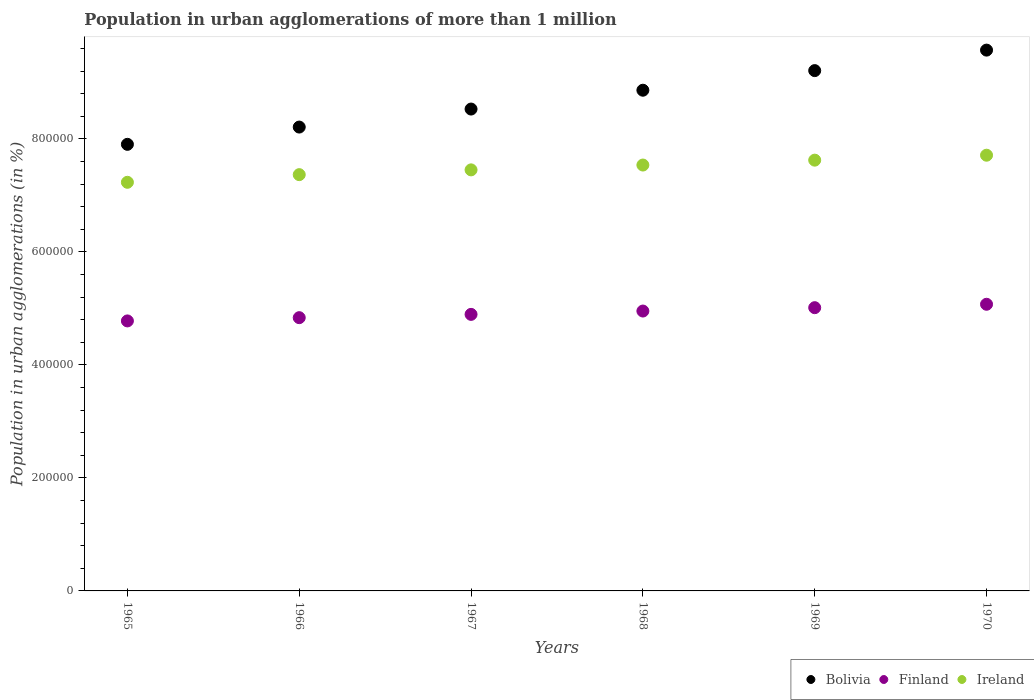Is the number of dotlines equal to the number of legend labels?
Make the answer very short. Yes. What is the population in urban agglomerations in Ireland in 1966?
Keep it short and to the point. 7.37e+05. Across all years, what is the maximum population in urban agglomerations in Finland?
Offer a terse response. 5.07e+05. Across all years, what is the minimum population in urban agglomerations in Bolivia?
Provide a succinct answer. 7.90e+05. In which year was the population in urban agglomerations in Finland maximum?
Your answer should be very brief. 1970. In which year was the population in urban agglomerations in Bolivia minimum?
Keep it short and to the point. 1965. What is the total population in urban agglomerations in Finland in the graph?
Offer a very short reply. 2.95e+06. What is the difference between the population in urban agglomerations in Ireland in 1965 and that in 1968?
Ensure brevity in your answer.  -3.06e+04. What is the difference between the population in urban agglomerations in Ireland in 1966 and the population in urban agglomerations in Bolivia in 1965?
Your response must be concise. -5.36e+04. What is the average population in urban agglomerations in Ireland per year?
Offer a terse response. 7.49e+05. In the year 1969, what is the difference between the population in urban agglomerations in Bolivia and population in urban agglomerations in Ireland?
Ensure brevity in your answer.  1.58e+05. What is the ratio of the population in urban agglomerations in Ireland in 1965 to that in 1970?
Provide a succinct answer. 0.94. Is the population in urban agglomerations in Bolivia in 1967 less than that in 1970?
Your answer should be compact. Yes. Is the difference between the population in urban agglomerations in Bolivia in 1966 and 1969 greater than the difference between the population in urban agglomerations in Ireland in 1966 and 1969?
Your answer should be compact. No. What is the difference between the highest and the second highest population in urban agglomerations in Finland?
Your answer should be compact. 6036. What is the difference between the highest and the lowest population in urban agglomerations in Finland?
Provide a short and direct response. 2.95e+04. In how many years, is the population in urban agglomerations in Finland greater than the average population in urban agglomerations in Finland taken over all years?
Provide a succinct answer. 3. Is the sum of the population in urban agglomerations in Ireland in 1969 and 1970 greater than the maximum population in urban agglomerations in Bolivia across all years?
Give a very brief answer. Yes. Is it the case that in every year, the sum of the population in urban agglomerations in Bolivia and population in urban agglomerations in Ireland  is greater than the population in urban agglomerations in Finland?
Your answer should be very brief. Yes. Is the population in urban agglomerations in Bolivia strictly less than the population in urban agglomerations in Ireland over the years?
Ensure brevity in your answer.  No. How many dotlines are there?
Keep it short and to the point. 3. How many years are there in the graph?
Ensure brevity in your answer.  6. Does the graph contain grids?
Ensure brevity in your answer.  No. Where does the legend appear in the graph?
Provide a succinct answer. Bottom right. How are the legend labels stacked?
Ensure brevity in your answer.  Horizontal. What is the title of the graph?
Provide a succinct answer. Population in urban agglomerations of more than 1 million. What is the label or title of the Y-axis?
Your answer should be compact. Population in urban agglomerations (in %). What is the Population in urban agglomerations (in %) of Bolivia in 1965?
Your answer should be compact. 7.90e+05. What is the Population in urban agglomerations (in %) in Finland in 1965?
Provide a succinct answer. 4.78e+05. What is the Population in urban agglomerations (in %) of Ireland in 1965?
Offer a terse response. 7.23e+05. What is the Population in urban agglomerations (in %) in Bolivia in 1966?
Give a very brief answer. 8.21e+05. What is the Population in urban agglomerations (in %) in Finland in 1966?
Your answer should be compact. 4.84e+05. What is the Population in urban agglomerations (in %) in Ireland in 1966?
Make the answer very short. 7.37e+05. What is the Population in urban agglomerations (in %) in Bolivia in 1967?
Offer a very short reply. 8.53e+05. What is the Population in urban agglomerations (in %) of Finland in 1967?
Keep it short and to the point. 4.89e+05. What is the Population in urban agglomerations (in %) in Ireland in 1967?
Offer a very short reply. 7.45e+05. What is the Population in urban agglomerations (in %) in Bolivia in 1968?
Your response must be concise. 8.86e+05. What is the Population in urban agglomerations (in %) in Finland in 1968?
Provide a succinct answer. 4.95e+05. What is the Population in urban agglomerations (in %) in Ireland in 1968?
Give a very brief answer. 7.54e+05. What is the Population in urban agglomerations (in %) of Bolivia in 1969?
Make the answer very short. 9.21e+05. What is the Population in urban agglomerations (in %) in Finland in 1969?
Offer a very short reply. 5.01e+05. What is the Population in urban agglomerations (in %) of Ireland in 1969?
Give a very brief answer. 7.62e+05. What is the Population in urban agglomerations (in %) of Bolivia in 1970?
Your answer should be compact. 9.57e+05. What is the Population in urban agglomerations (in %) in Finland in 1970?
Your response must be concise. 5.07e+05. What is the Population in urban agglomerations (in %) in Ireland in 1970?
Your answer should be very brief. 7.71e+05. Across all years, what is the maximum Population in urban agglomerations (in %) of Bolivia?
Your answer should be very brief. 9.57e+05. Across all years, what is the maximum Population in urban agglomerations (in %) of Finland?
Your response must be concise. 5.07e+05. Across all years, what is the maximum Population in urban agglomerations (in %) in Ireland?
Keep it short and to the point. 7.71e+05. Across all years, what is the minimum Population in urban agglomerations (in %) of Bolivia?
Offer a terse response. 7.90e+05. Across all years, what is the minimum Population in urban agglomerations (in %) of Finland?
Give a very brief answer. 4.78e+05. Across all years, what is the minimum Population in urban agglomerations (in %) in Ireland?
Give a very brief answer. 7.23e+05. What is the total Population in urban agglomerations (in %) of Bolivia in the graph?
Provide a succinct answer. 5.23e+06. What is the total Population in urban agglomerations (in %) of Finland in the graph?
Offer a terse response. 2.95e+06. What is the total Population in urban agglomerations (in %) of Ireland in the graph?
Ensure brevity in your answer.  4.49e+06. What is the difference between the Population in urban agglomerations (in %) of Bolivia in 1965 and that in 1966?
Offer a terse response. -3.06e+04. What is the difference between the Population in urban agglomerations (in %) in Finland in 1965 and that in 1966?
Give a very brief answer. -5754. What is the difference between the Population in urban agglomerations (in %) of Ireland in 1965 and that in 1966?
Offer a terse response. -1.35e+04. What is the difference between the Population in urban agglomerations (in %) in Bolivia in 1965 and that in 1967?
Offer a terse response. -6.24e+04. What is the difference between the Population in urban agglomerations (in %) in Finland in 1965 and that in 1967?
Make the answer very short. -1.16e+04. What is the difference between the Population in urban agglomerations (in %) of Ireland in 1965 and that in 1967?
Provide a succinct answer. -2.20e+04. What is the difference between the Population in urban agglomerations (in %) of Bolivia in 1965 and that in 1968?
Offer a very short reply. -9.58e+04. What is the difference between the Population in urban agglomerations (in %) in Finland in 1965 and that in 1968?
Give a very brief answer. -1.75e+04. What is the difference between the Population in urban agglomerations (in %) of Ireland in 1965 and that in 1968?
Ensure brevity in your answer.  -3.06e+04. What is the difference between the Population in urban agglomerations (in %) in Bolivia in 1965 and that in 1969?
Your answer should be very brief. -1.30e+05. What is the difference between the Population in urban agglomerations (in %) of Finland in 1965 and that in 1969?
Provide a succinct answer. -2.34e+04. What is the difference between the Population in urban agglomerations (in %) in Ireland in 1965 and that in 1969?
Your answer should be compact. -3.92e+04. What is the difference between the Population in urban agglomerations (in %) in Bolivia in 1965 and that in 1970?
Provide a succinct answer. -1.67e+05. What is the difference between the Population in urban agglomerations (in %) in Finland in 1965 and that in 1970?
Provide a short and direct response. -2.95e+04. What is the difference between the Population in urban agglomerations (in %) of Ireland in 1965 and that in 1970?
Offer a very short reply. -4.79e+04. What is the difference between the Population in urban agglomerations (in %) of Bolivia in 1966 and that in 1967?
Offer a very short reply. -3.19e+04. What is the difference between the Population in urban agglomerations (in %) in Finland in 1966 and that in 1967?
Your response must be concise. -5823. What is the difference between the Population in urban agglomerations (in %) in Ireland in 1966 and that in 1967?
Give a very brief answer. -8451. What is the difference between the Population in urban agglomerations (in %) of Bolivia in 1966 and that in 1968?
Make the answer very short. -6.52e+04. What is the difference between the Population in urban agglomerations (in %) of Finland in 1966 and that in 1968?
Your answer should be compact. -1.17e+04. What is the difference between the Population in urban agglomerations (in %) in Ireland in 1966 and that in 1968?
Your answer should be compact. -1.70e+04. What is the difference between the Population in urban agglomerations (in %) in Bolivia in 1966 and that in 1969?
Your answer should be very brief. -9.99e+04. What is the difference between the Population in urban agglomerations (in %) in Finland in 1966 and that in 1969?
Provide a succinct answer. -1.77e+04. What is the difference between the Population in urban agglomerations (in %) of Ireland in 1966 and that in 1969?
Your response must be concise. -2.56e+04. What is the difference between the Population in urban agglomerations (in %) of Bolivia in 1966 and that in 1970?
Your answer should be very brief. -1.36e+05. What is the difference between the Population in urban agglomerations (in %) of Finland in 1966 and that in 1970?
Give a very brief answer. -2.37e+04. What is the difference between the Population in urban agglomerations (in %) in Ireland in 1966 and that in 1970?
Your answer should be compact. -3.44e+04. What is the difference between the Population in urban agglomerations (in %) in Bolivia in 1967 and that in 1968?
Offer a very short reply. -3.33e+04. What is the difference between the Population in urban agglomerations (in %) of Finland in 1967 and that in 1968?
Make the answer very short. -5902. What is the difference between the Population in urban agglomerations (in %) in Ireland in 1967 and that in 1968?
Your answer should be very brief. -8560. What is the difference between the Population in urban agglomerations (in %) of Bolivia in 1967 and that in 1969?
Give a very brief answer. -6.80e+04. What is the difference between the Population in urban agglomerations (in %) in Finland in 1967 and that in 1969?
Offer a very short reply. -1.19e+04. What is the difference between the Population in urban agglomerations (in %) in Ireland in 1967 and that in 1969?
Give a very brief answer. -1.72e+04. What is the difference between the Population in urban agglomerations (in %) in Bolivia in 1967 and that in 1970?
Offer a terse response. -1.04e+05. What is the difference between the Population in urban agglomerations (in %) in Finland in 1967 and that in 1970?
Your response must be concise. -1.79e+04. What is the difference between the Population in urban agglomerations (in %) in Ireland in 1967 and that in 1970?
Your answer should be very brief. -2.59e+04. What is the difference between the Population in urban agglomerations (in %) in Bolivia in 1968 and that in 1969?
Give a very brief answer. -3.47e+04. What is the difference between the Population in urban agglomerations (in %) in Finland in 1968 and that in 1969?
Offer a terse response. -5956. What is the difference between the Population in urban agglomerations (in %) of Ireland in 1968 and that in 1969?
Make the answer very short. -8634. What is the difference between the Population in urban agglomerations (in %) of Bolivia in 1968 and that in 1970?
Ensure brevity in your answer.  -7.10e+04. What is the difference between the Population in urban agglomerations (in %) in Finland in 1968 and that in 1970?
Keep it short and to the point. -1.20e+04. What is the difference between the Population in urban agglomerations (in %) in Ireland in 1968 and that in 1970?
Give a very brief answer. -1.74e+04. What is the difference between the Population in urban agglomerations (in %) of Bolivia in 1969 and that in 1970?
Ensure brevity in your answer.  -3.63e+04. What is the difference between the Population in urban agglomerations (in %) in Finland in 1969 and that in 1970?
Your answer should be very brief. -6036. What is the difference between the Population in urban agglomerations (in %) in Ireland in 1969 and that in 1970?
Offer a very short reply. -8746. What is the difference between the Population in urban agglomerations (in %) of Bolivia in 1965 and the Population in urban agglomerations (in %) of Finland in 1966?
Keep it short and to the point. 3.07e+05. What is the difference between the Population in urban agglomerations (in %) of Bolivia in 1965 and the Population in urban agglomerations (in %) of Ireland in 1966?
Provide a succinct answer. 5.36e+04. What is the difference between the Population in urban agglomerations (in %) of Finland in 1965 and the Population in urban agglomerations (in %) of Ireland in 1966?
Your answer should be compact. -2.59e+05. What is the difference between the Population in urban agglomerations (in %) of Bolivia in 1965 and the Population in urban agglomerations (in %) of Finland in 1967?
Provide a short and direct response. 3.01e+05. What is the difference between the Population in urban agglomerations (in %) of Bolivia in 1965 and the Population in urban agglomerations (in %) of Ireland in 1967?
Ensure brevity in your answer.  4.52e+04. What is the difference between the Population in urban agglomerations (in %) in Finland in 1965 and the Population in urban agglomerations (in %) in Ireland in 1967?
Give a very brief answer. -2.67e+05. What is the difference between the Population in urban agglomerations (in %) of Bolivia in 1965 and the Population in urban agglomerations (in %) of Finland in 1968?
Provide a short and direct response. 2.95e+05. What is the difference between the Population in urban agglomerations (in %) of Bolivia in 1965 and the Population in urban agglomerations (in %) of Ireland in 1968?
Your answer should be compact. 3.66e+04. What is the difference between the Population in urban agglomerations (in %) in Finland in 1965 and the Population in urban agglomerations (in %) in Ireland in 1968?
Give a very brief answer. -2.76e+05. What is the difference between the Population in urban agglomerations (in %) of Bolivia in 1965 and the Population in urban agglomerations (in %) of Finland in 1969?
Make the answer very short. 2.89e+05. What is the difference between the Population in urban agglomerations (in %) of Bolivia in 1965 and the Population in urban agglomerations (in %) of Ireland in 1969?
Your response must be concise. 2.80e+04. What is the difference between the Population in urban agglomerations (in %) of Finland in 1965 and the Population in urban agglomerations (in %) of Ireland in 1969?
Offer a terse response. -2.85e+05. What is the difference between the Population in urban agglomerations (in %) in Bolivia in 1965 and the Population in urban agglomerations (in %) in Finland in 1970?
Your response must be concise. 2.83e+05. What is the difference between the Population in urban agglomerations (in %) in Bolivia in 1965 and the Population in urban agglomerations (in %) in Ireland in 1970?
Keep it short and to the point. 1.93e+04. What is the difference between the Population in urban agglomerations (in %) of Finland in 1965 and the Population in urban agglomerations (in %) of Ireland in 1970?
Give a very brief answer. -2.93e+05. What is the difference between the Population in urban agglomerations (in %) of Bolivia in 1966 and the Population in urban agglomerations (in %) of Finland in 1967?
Give a very brief answer. 3.31e+05. What is the difference between the Population in urban agglomerations (in %) in Bolivia in 1966 and the Population in urban agglomerations (in %) in Ireland in 1967?
Your answer should be very brief. 7.58e+04. What is the difference between the Population in urban agglomerations (in %) of Finland in 1966 and the Population in urban agglomerations (in %) of Ireland in 1967?
Offer a very short reply. -2.62e+05. What is the difference between the Population in urban agglomerations (in %) in Bolivia in 1966 and the Population in urban agglomerations (in %) in Finland in 1968?
Make the answer very short. 3.26e+05. What is the difference between the Population in urban agglomerations (in %) in Bolivia in 1966 and the Population in urban agglomerations (in %) in Ireland in 1968?
Keep it short and to the point. 6.72e+04. What is the difference between the Population in urban agglomerations (in %) in Finland in 1966 and the Population in urban agglomerations (in %) in Ireland in 1968?
Offer a terse response. -2.70e+05. What is the difference between the Population in urban agglomerations (in %) in Bolivia in 1966 and the Population in urban agglomerations (in %) in Finland in 1969?
Your answer should be very brief. 3.20e+05. What is the difference between the Population in urban agglomerations (in %) of Bolivia in 1966 and the Population in urban agglomerations (in %) of Ireland in 1969?
Your response must be concise. 5.86e+04. What is the difference between the Population in urban agglomerations (in %) of Finland in 1966 and the Population in urban agglomerations (in %) of Ireland in 1969?
Ensure brevity in your answer.  -2.79e+05. What is the difference between the Population in urban agglomerations (in %) of Bolivia in 1966 and the Population in urban agglomerations (in %) of Finland in 1970?
Ensure brevity in your answer.  3.14e+05. What is the difference between the Population in urban agglomerations (in %) in Bolivia in 1966 and the Population in urban agglomerations (in %) in Ireland in 1970?
Provide a succinct answer. 4.98e+04. What is the difference between the Population in urban agglomerations (in %) of Finland in 1966 and the Population in urban agglomerations (in %) of Ireland in 1970?
Provide a succinct answer. -2.88e+05. What is the difference between the Population in urban agglomerations (in %) of Bolivia in 1967 and the Population in urban agglomerations (in %) of Finland in 1968?
Give a very brief answer. 3.57e+05. What is the difference between the Population in urban agglomerations (in %) in Bolivia in 1967 and the Population in urban agglomerations (in %) in Ireland in 1968?
Offer a very short reply. 9.91e+04. What is the difference between the Population in urban agglomerations (in %) in Finland in 1967 and the Population in urban agglomerations (in %) in Ireland in 1968?
Make the answer very short. -2.64e+05. What is the difference between the Population in urban agglomerations (in %) in Bolivia in 1967 and the Population in urban agglomerations (in %) in Finland in 1969?
Your answer should be compact. 3.52e+05. What is the difference between the Population in urban agglomerations (in %) in Bolivia in 1967 and the Population in urban agglomerations (in %) in Ireland in 1969?
Offer a very short reply. 9.04e+04. What is the difference between the Population in urban agglomerations (in %) of Finland in 1967 and the Population in urban agglomerations (in %) of Ireland in 1969?
Provide a succinct answer. -2.73e+05. What is the difference between the Population in urban agglomerations (in %) of Bolivia in 1967 and the Population in urban agglomerations (in %) of Finland in 1970?
Make the answer very short. 3.45e+05. What is the difference between the Population in urban agglomerations (in %) in Bolivia in 1967 and the Population in urban agglomerations (in %) in Ireland in 1970?
Your answer should be compact. 8.17e+04. What is the difference between the Population in urban agglomerations (in %) of Finland in 1967 and the Population in urban agglomerations (in %) of Ireland in 1970?
Your answer should be very brief. -2.82e+05. What is the difference between the Population in urban agglomerations (in %) in Bolivia in 1968 and the Population in urban agglomerations (in %) in Finland in 1969?
Make the answer very short. 3.85e+05. What is the difference between the Population in urban agglomerations (in %) in Bolivia in 1968 and the Population in urban agglomerations (in %) in Ireland in 1969?
Ensure brevity in your answer.  1.24e+05. What is the difference between the Population in urban agglomerations (in %) in Finland in 1968 and the Population in urban agglomerations (in %) in Ireland in 1969?
Make the answer very short. -2.67e+05. What is the difference between the Population in urban agglomerations (in %) of Bolivia in 1968 and the Population in urban agglomerations (in %) of Finland in 1970?
Ensure brevity in your answer.  3.79e+05. What is the difference between the Population in urban agglomerations (in %) of Bolivia in 1968 and the Population in urban agglomerations (in %) of Ireland in 1970?
Provide a succinct answer. 1.15e+05. What is the difference between the Population in urban agglomerations (in %) of Finland in 1968 and the Population in urban agglomerations (in %) of Ireland in 1970?
Keep it short and to the point. -2.76e+05. What is the difference between the Population in urban agglomerations (in %) in Bolivia in 1969 and the Population in urban agglomerations (in %) in Finland in 1970?
Your answer should be compact. 4.14e+05. What is the difference between the Population in urban agglomerations (in %) in Bolivia in 1969 and the Population in urban agglomerations (in %) in Ireland in 1970?
Your answer should be compact. 1.50e+05. What is the difference between the Population in urban agglomerations (in %) in Finland in 1969 and the Population in urban agglomerations (in %) in Ireland in 1970?
Provide a succinct answer. -2.70e+05. What is the average Population in urban agglomerations (in %) of Bolivia per year?
Offer a very short reply. 8.71e+05. What is the average Population in urban agglomerations (in %) of Finland per year?
Your answer should be very brief. 4.92e+05. What is the average Population in urban agglomerations (in %) of Ireland per year?
Your answer should be very brief. 7.49e+05. In the year 1965, what is the difference between the Population in urban agglomerations (in %) of Bolivia and Population in urban agglomerations (in %) of Finland?
Your answer should be compact. 3.13e+05. In the year 1965, what is the difference between the Population in urban agglomerations (in %) of Bolivia and Population in urban agglomerations (in %) of Ireland?
Provide a succinct answer. 6.72e+04. In the year 1965, what is the difference between the Population in urban agglomerations (in %) of Finland and Population in urban agglomerations (in %) of Ireland?
Give a very brief answer. -2.45e+05. In the year 1966, what is the difference between the Population in urban agglomerations (in %) of Bolivia and Population in urban agglomerations (in %) of Finland?
Offer a very short reply. 3.37e+05. In the year 1966, what is the difference between the Population in urban agglomerations (in %) in Bolivia and Population in urban agglomerations (in %) in Ireland?
Your answer should be very brief. 8.42e+04. In the year 1966, what is the difference between the Population in urban agglomerations (in %) of Finland and Population in urban agglomerations (in %) of Ireland?
Provide a succinct answer. -2.53e+05. In the year 1967, what is the difference between the Population in urban agglomerations (in %) of Bolivia and Population in urban agglomerations (in %) of Finland?
Ensure brevity in your answer.  3.63e+05. In the year 1967, what is the difference between the Population in urban agglomerations (in %) of Bolivia and Population in urban agglomerations (in %) of Ireland?
Ensure brevity in your answer.  1.08e+05. In the year 1967, what is the difference between the Population in urban agglomerations (in %) of Finland and Population in urban agglomerations (in %) of Ireland?
Your answer should be compact. -2.56e+05. In the year 1968, what is the difference between the Population in urban agglomerations (in %) of Bolivia and Population in urban agglomerations (in %) of Finland?
Make the answer very short. 3.91e+05. In the year 1968, what is the difference between the Population in urban agglomerations (in %) in Bolivia and Population in urban agglomerations (in %) in Ireland?
Offer a terse response. 1.32e+05. In the year 1968, what is the difference between the Population in urban agglomerations (in %) of Finland and Population in urban agglomerations (in %) of Ireland?
Keep it short and to the point. -2.58e+05. In the year 1969, what is the difference between the Population in urban agglomerations (in %) in Bolivia and Population in urban agglomerations (in %) in Finland?
Make the answer very short. 4.20e+05. In the year 1969, what is the difference between the Population in urban agglomerations (in %) in Bolivia and Population in urban agglomerations (in %) in Ireland?
Give a very brief answer. 1.58e+05. In the year 1969, what is the difference between the Population in urban agglomerations (in %) in Finland and Population in urban agglomerations (in %) in Ireland?
Your answer should be compact. -2.61e+05. In the year 1970, what is the difference between the Population in urban agglomerations (in %) of Bolivia and Population in urban agglomerations (in %) of Finland?
Your answer should be very brief. 4.50e+05. In the year 1970, what is the difference between the Population in urban agglomerations (in %) in Bolivia and Population in urban agglomerations (in %) in Ireland?
Your answer should be compact. 1.86e+05. In the year 1970, what is the difference between the Population in urban agglomerations (in %) of Finland and Population in urban agglomerations (in %) of Ireland?
Your response must be concise. -2.64e+05. What is the ratio of the Population in urban agglomerations (in %) of Bolivia in 1965 to that in 1966?
Ensure brevity in your answer.  0.96. What is the ratio of the Population in urban agglomerations (in %) in Finland in 1965 to that in 1966?
Offer a very short reply. 0.99. What is the ratio of the Population in urban agglomerations (in %) of Ireland in 1965 to that in 1966?
Provide a succinct answer. 0.98. What is the ratio of the Population in urban agglomerations (in %) of Bolivia in 1965 to that in 1967?
Provide a short and direct response. 0.93. What is the ratio of the Population in urban agglomerations (in %) in Finland in 1965 to that in 1967?
Ensure brevity in your answer.  0.98. What is the ratio of the Population in urban agglomerations (in %) of Ireland in 1965 to that in 1967?
Keep it short and to the point. 0.97. What is the ratio of the Population in urban agglomerations (in %) in Bolivia in 1965 to that in 1968?
Provide a short and direct response. 0.89. What is the ratio of the Population in urban agglomerations (in %) in Finland in 1965 to that in 1968?
Offer a terse response. 0.96. What is the ratio of the Population in urban agglomerations (in %) of Ireland in 1965 to that in 1968?
Offer a terse response. 0.96. What is the ratio of the Population in urban agglomerations (in %) of Bolivia in 1965 to that in 1969?
Give a very brief answer. 0.86. What is the ratio of the Population in urban agglomerations (in %) of Finland in 1965 to that in 1969?
Your response must be concise. 0.95. What is the ratio of the Population in urban agglomerations (in %) in Ireland in 1965 to that in 1969?
Keep it short and to the point. 0.95. What is the ratio of the Population in urban agglomerations (in %) of Bolivia in 1965 to that in 1970?
Offer a very short reply. 0.83. What is the ratio of the Population in urban agglomerations (in %) of Finland in 1965 to that in 1970?
Ensure brevity in your answer.  0.94. What is the ratio of the Population in urban agglomerations (in %) in Ireland in 1965 to that in 1970?
Ensure brevity in your answer.  0.94. What is the ratio of the Population in urban agglomerations (in %) of Bolivia in 1966 to that in 1967?
Keep it short and to the point. 0.96. What is the ratio of the Population in urban agglomerations (in %) of Finland in 1966 to that in 1967?
Your answer should be compact. 0.99. What is the ratio of the Population in urban agglomerations (in %) of Ireland in 1966 to that in 1967?
Offer a terse response. 0.99. What is the ratio of the Population in urban agglomerations (in %) of Bolivia in 1966 to that in 1968?
Offer a terse response. 0.93. What is the ratio of the Population in urban agglomerations (in %) of Finland in 1966 to that in 1968?
Your response must be concise. 0.98. What is the ratio of the Population in urban agglomerations (in %) in Ireland in 1966 to that in 1968?
Offer a terse response. 0.98. What is the ratio of the Population in urban agglomerations (in %) of Bolivia in 1966 to that in 1969?
Your answer should be compact. 0.89. What is the ratio of the Population in urban agglomerations (in %) of Finland in 1966 to that in 1969?
Your response must be concise. 0.96. What is the ratio of the Population in urban agglomerations (in %) in Ireland in 1966 to that in 1969?
Provide a short and direct response. 0.97. What is the ratio of the Population in urban agglomerations (in %) of Bolivia in 1966 to that in 1970?
Offer a very short reply. 0.86. What is the ratio of the Population in urban agglomerations (in %) of Finland in 1966 to that in 1970?
Provide a succinct answer. 0.95. What is the ratio of the Population in urban agglomerations (in %) in Ireland in 1966 to that in 1970?
Provide a succinct answer. 0.96. What is the ratio of the Population in urban agglomerations (in %) in Bolivia in 1967 to that in 1968?
Give a very brief answer. 0.96. What is the ratio of the Population in urban agglomerations (in %) in Finland in 1967 to that in 1968?
Give a very brief answer. 0.99. What is the ratio of the Population in urban agglomerations (in %) of Ireland in 1967 to that in 1968?
Ensure brevity in your answer.  0.99. What is the ratio of the Population in urban agglomerations (in %) in Bolivia in 1967 to that in 1969?
Make the answer very short. 0.93. What is the ratio of the Population in urban agglomerations (in %) of Finland in 1967 to that in 1969?
Provide a short and direct response. 0.98. What is the ratio of the Population in urban agglomerations (in %) of Ireland in 1967 to that in 1969?
Provide a succinct answer. 0.98. What is the ratio of the Population in urban agglomerations (in %) in Bolivia in 1967 to that in 1970?
Provide a succinct answer. 0.89. What is the ratio of the Population in urban agglomerations (in %) in Finland in 1967 to that in 1970?
Make the answer very short. 0.96. What is the ratio of the Population in urban agglomerations (in %) in Ireland in 1967 to that in 1970?
Your answer should be compact. 0.97. What is the ratio of the Population in urban agglomerations (in %) of Bolivia in 1968 to that in 1969?
Your answer should be compact. 0.96. What is the ratio of the Population in urban agglomerations (in %) of Ireland in 1968 to that in 1969?
Offer a very short reply. 0.99. What is the ratio of the Population in urban agglomerations (in %) in Bolivia in 1968 to that in 1970?
Provide a succinct answer. 0.93. What is the ratio of the Population in urban agglomerations (in %) of Finland in 1968 to that in 1970?
Your answer should be compact. 0.98. What is the ratio of the Population in urban agglomerations (in %) of Ireland in 1968 to that in 1970?
Keep it short and to the point. 0.98. What is the ratio of the Population in urban agglomerations (in %) of Bolivia in 1969 to that in 1970?
Provide a succinct answer. 0.96. What is the ratio of the Population in urban agglomerations (in %) in Finland in 1969 to that in 1970?
Give a very brief answer. 0.99. What is the ratio of the Population in urban agglomerations (in %) of Ireland in 1969 to that in 1970?
Provide a short and direct response. 0.99. What is the difference between the highest and the second highest Population in urban agglomerations (in %) in Bolivia?
Give a very brief answer. 3.63e+04. What is the difference between the highest and the second highest Population in urban agglomerations (in %) of Finland?
Your answer should be compact. 6036. What is the difference between the highest and the second highest Population in urban agglomerations (in %) of Ireland?
Ensure brevity in your answer.  8746. What is the difference between the highest and the lowest Population in urban agglomerations (in %) in Bolivia?
Keep it short and to the point. 1.67e+05. What is the difference between the highest and the lowest Population in urban agglomerations (in %) of Finland?
Your answer should be very brief. 2.95e+04. What is the difference between the highest and the lowest Population in urban agglomerations (in %) of Ireland?
Provide a succinct answer. 4.79e+04. 